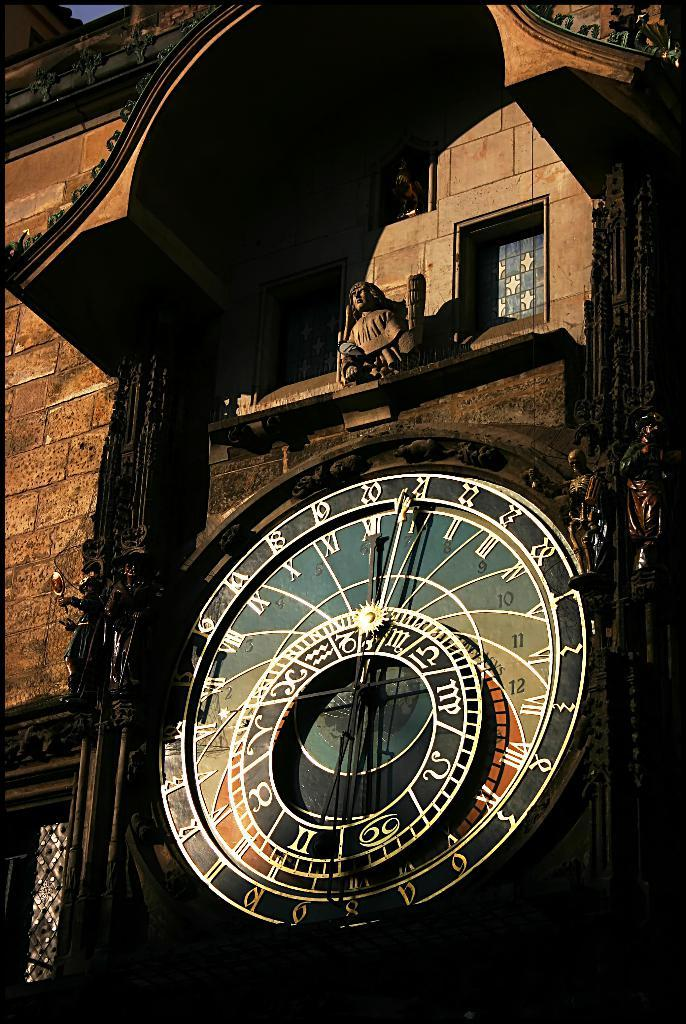What is located in the foreground of the image? There is a clock, a sculpture, windows, and an arch of a building in the foreground of the image. Can you describe the clock be used to tell time in the image? Yes, the clock in the foreground of the image can be used to tell time. What architectural feature is present in the foreground of the image? The arch of a building is present in the foreground of the image. How many beggars can be seen sitting on the seat in the image? There are no beggars or seats present in the image. What type of answer is provided by the sculpture in the image? The sculpture in the image is not providing any answers, as it is a static object. 